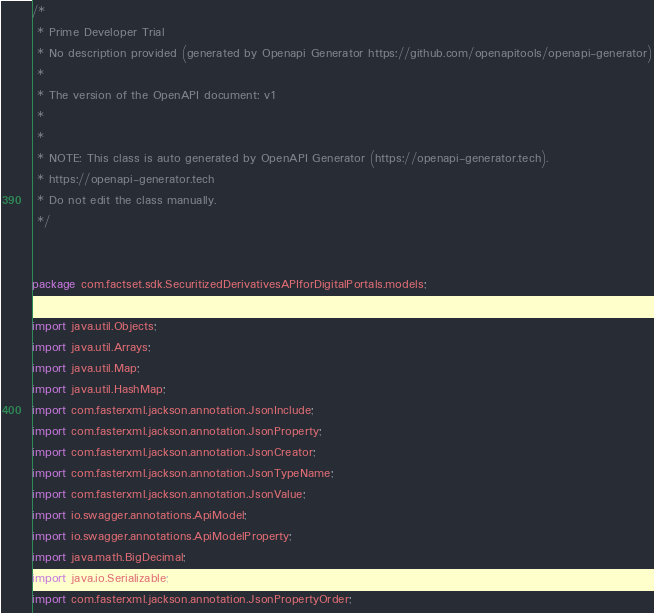Convert code to text. <code><loc_0><loc_0><loc_500><loc_500><_Java_>/*
 * Prime Developer Trial
 * No description provided (generated by Openapi Generator https://github.com/openapitools/openapi-generator)
 *
 * The version of the OpenAPI document: v1
 * 
 *
 * NOTE: This class is auto generated by OpenAPI Generator (https://openapi-generator.tech).
 * https://openapi-generator.tech
 * Do not edit the class manually.
 */


package com.factset.sdk.SecuritizedDerivativesAPIforDigitalPortals.models;

import java.util.Objects;
import java.util.Arrays;
import java.util.Map;
import java.util.HashMap;
import com.fasterxml.jackson.annotation.JsonInclude;
import com.fasterxml.jackson.annotation.JsonProperty;
import com.fasterxml.jackson.annotation.JsonCreator;
import com.fasterxml.jackson.annotation.JsonTypeName;
import com.fasterxml.jackson.annotation.JsonValue;
import io.swagger.annotations.ApiModel;
import io.swagger.annotations.ApiModelProperty;
import java.math.BigDecimal;
import java.io.Serializable;
import com.fasterxml.jackson.annotation.JsonPropertyOrder;</code> 